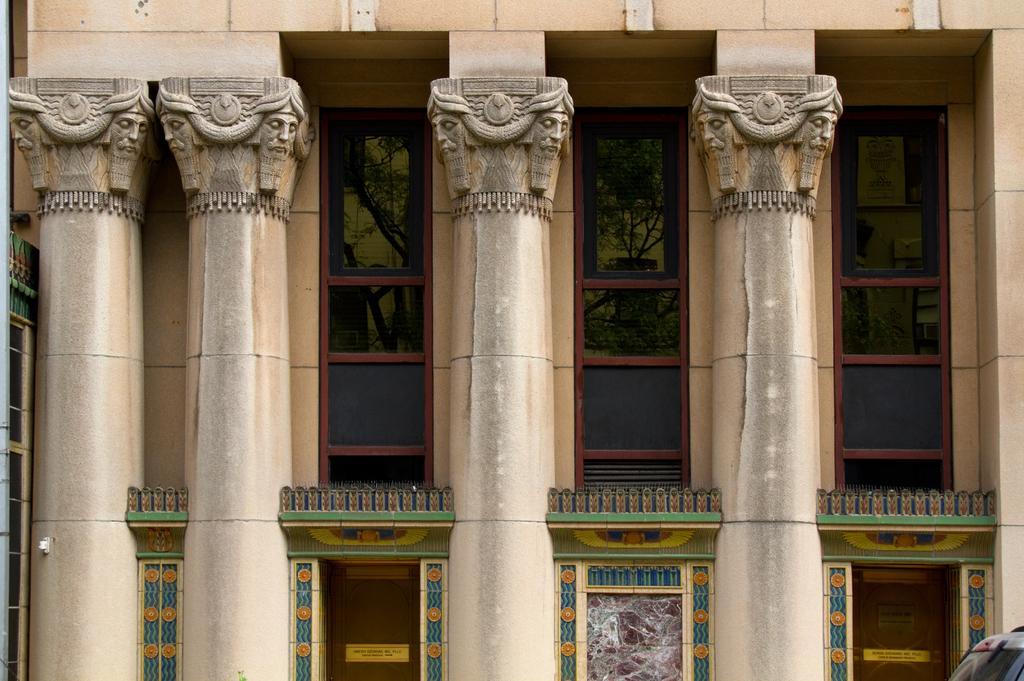Can you describe this image briefly? In the foreground I can see pillars, sculptures, fence, wall paintings on a wall. This image is taken during a day. 